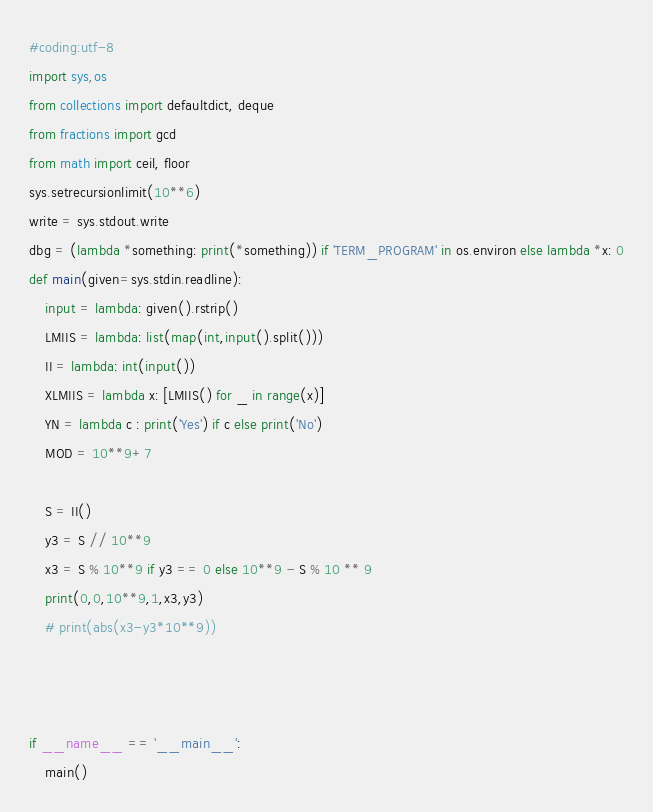<code> <loc_0><loc_0><loc_500><loc_500><_Python_>#coding:utf-8
import sys,os
from collections import defaultdict, deque
from fractions import gcd
from math import ceil, floor
sys.setrecursionlimit(10**6)
write = sys.stdout.write
dbg = (lambda *something: print(*something)) if 'TERM_PROGRAM' in os.environ else lambda *x: 0
def main(given=sys.stdin.readline):
    input = lambda: given().rstrip()
    LMIIS = lambda: list(map(int,input().split()))
    II = lambda: int(input())
    XLMIIS = lambda x: [LMIIS() for _ in range(x)]
    YN = lambda c : print('Yes') if c else print('No')
    MOD = 10**9+7

    S = II()
    y3 = S // 10**9
    x3 = S % 10**9 if y3 == 0 else 10**9 - S % 10 ** 9
    print(0,0,10**9,1,x3,y3)
    # print(abs(x3-y3*10**9))



if __name__ == '__main__':
    main()</code> 